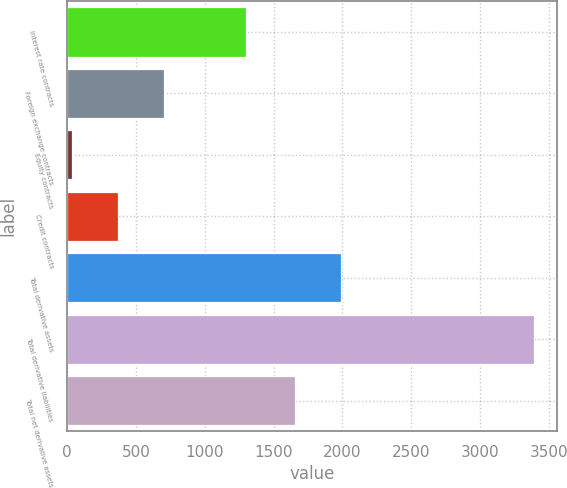Convert chart. <chart><loc_0><loc_0><loc_500><loc_500><bar_chart><fcel>Interest rate contracts<fcel>Foreign exchange contracts<fcel>Equity contracts<fcel>Credit contracts<fcel>Total derivative assets<fcel>Total derivative liabilities<fcel>Total net derivative assets<nl><fcel>1297<fcel>707.2<fcel>36<fcel>371.6<fcel>1991.6<fcel>3392<fcel>1656<nl></chart> 